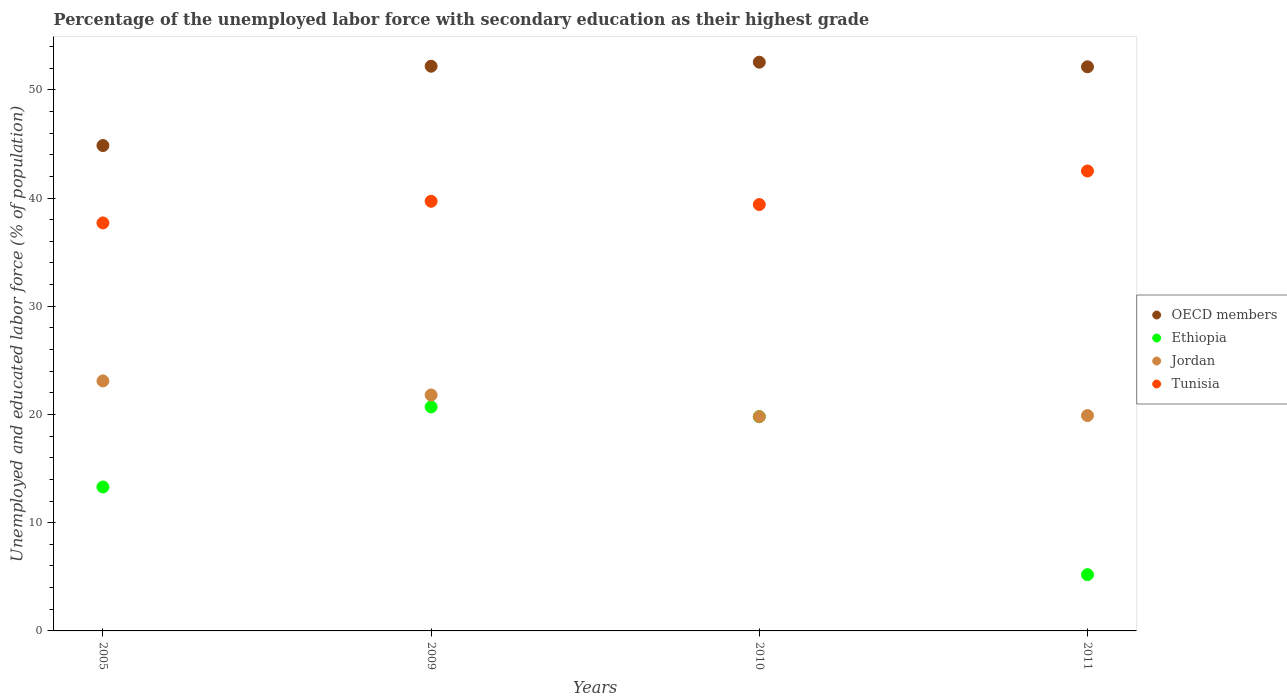What is the percentage of the unemployed labor force with secondary education in Ethiopia in 2009?
Keep it short and to the point. 20.7. Across all years, what is the maximum percentage of the unemployed labor force with secondary education in Jordan?
Ensure brevity in your answer.  23.1. Across all years, what is the minimum percentage of the unemployed labor force with secondary education in Ethiopia?
Make the answer very short. 5.2. What is the total percentage of the unemployed labor force with secondary education in Jordan in the graph?
Your answer should be very brief. 84.6. What is the difference between the percentage of the unemployed labor force with secondary education in Ethiopia in 2009 and that in 2011?
Your answer should be compact. 15.5. What is the difference between the percentage of the unemployed labor force with secondary education in OECD members in 2011 and the percentage of the unemployed labor force with secondary education in Jordan in 2010?
Give a very brief answer. 32.33. What is the average percentage of the unemployed labor force with secondary education in OECD members per year?
Keep it short and to the point. 50.43. In the year 2005, what is the difference between the percentage of the unemployed labor force with secondary education in OECD members and percentage of the unemployed labor force with secondary education in Ethiopia?
Provide a short and direct response. 31.55. What is the ratio of the percentage of the unemployed labor force with secondary education in OECD members in 2005 to that in 2010?
Make the answer very short. 0.85. Is the difference between the percentage of the unemployed labor force with secondary education in OECD members in 2010 and 2011 greater than the difference between the percentage of the unemployed labor force with secondary education in Ethiopia in 2010 and 2011?
Provide a short and direct response. No. What is the difference between the highest and the second highest percentage of the unemployed labor force with secondary education in Ethiopia?
Make the answer very short. 0.9. What is the difference between the highest and the lowest percentage of the unemployed labor force with secondary education in Jordan?
Keep it short and to the point. 3.3. Is it the case that in every year, the sum of the percentage of the unemployed labor force with secondary education in Jordan and percentage of the unemployed labor force with secondary education in Ethiopia  is greater than the sum of percentage of the unemployed labor force with secondary education in OECD members and percentage of the unemployed labor force with secondary education in Tunisia?
Your answer should be very brief. Yes. Is it the case that in every year, the sum of the percentage of the unemployed labor force with secondary education in OECD members and percentage of the unemployed labor force with secondary education in Jordan  is greater than the percentage of the unemployed labor force with secondary education in Tunisia?
Give a very brief answer. Yes. Is the percentage of the unemployed labor force with secondary education in Ethiopia strictly less than the percentage of the unemployed labor force with secondary education in OECD members over the years?
Your answer should be very brief. Yes. How many dotlines are there?
Offer a very short reply. 4. How many years are there in the graph?
Make the answer very short. 4. What is the difference between two consecutive major ticks on the Y-axis?
Make the answer very short. 10. Are the values on the major ticks of Y-axis written in scientific E-notation?
Your response must be concise. No. Does the graph contain any zero values?
Offer a terse response. No. Where does the legend appear in the graph?
Make the answer very short. Center right. How are the legend labels stacked?
Your answer should be very brief. Vertical. What is the title of the graph?
Provide a succinct answer. Percentage of the unemployed labor force with secondary education as their highest grade. Does "Tuvalu" appear as one of the legend labels in the graph?
Offer a terse response. No. What is the label or title of the X-axis?
Keep it short and to the point. Years. What is the label or title of the Y-axis?
Your answer should be very brief. Unemployed and educated labor force (% of population). What is the Unemployed and educated labor force (% of population) of OECD members in 2005?
Provide a succinct answer. 44.85. What is the Unemployed and educated labor force (% of population) in Ethiopia in 2005?
Your response must be concise. 13.3. What is the Unemployed and educated labor force (% of population) in Jordan in 2005?
Provide a succinct answer. 23.1. What is the Unemployed and educated labor force (% of population) of Tunisia in 2005?
Make the answer very short. 37.7. What is the Unemployed and educated labor force (% of population) of OECD members in 2009?
Your answer should be very brief. 52.18. What is the Unemployed and educated labor force (% of population) of Ethiopia in 2009?
Keep it short and to the point. 20.7. What is the Unemployed and educated labor force (% of population) of Jordan in 2009?
Make the answer very short. 21.8. What is the Unemployed and educated labor force (% of population) in Tunisia in 2009?
Ensure brevity in your answer.  39.7. What is the Unemployed and educated labor force (% of population) in OECD members in 2010?
Offer a very short reply. 52.55. What is the Unemployed and educated labor force (% of population) in Ethiopia in 2010?
Provide a short and direct response. 19.8. What is the Unemployed and educated labor force (% of population) in Jordan in 2010?
Provide a succinct answer. 19.8. What is the Unemployed and educated labor force (% of population) in Tunisia in 2010?
Offer a terse response. 39.4. What is the Unemployed and educated labor force (% of population) in OECD members in 2011?
Your answer should be very brief. 52.13. What is the Unemployed and educated labor force (% of population) in Ethiopia in 2011?
Offer a terse response. 5.2. What is the Unemployed and educated labor force (% of population) of Jordan in 2011?
Your response must be concise. 19.9. What is the Unemployed and educated labor force (% of population) in Tunisia in 2011?
Give a very brief answer. 42.5. Across all years, what is the maximum Unemployed and educated labor force (% of population) of OECD members?
Your response must be concise. 52.55. Across all years, what is the maximum Unemployed and educated labor force (% of population) of Ethiopia?
Ensure brevity in your answer.  20.7. Across all years, what is the maximum Unemployed and educated labor force (% of population) in Jordan?
Offer a very short reply. 23.1. Across all years, what is the maximum Unemployed and educated labor force (% of population) in Tunisia?
Offer a terse response. 42.5. Across all years, what is the minimum Unemployed and educated labor force (% of population) of OECD members?
Your response must be concise. 44.85. Across all years, what is the minimum Unemployed and educated labor force (% of population) in Ethiopia?
Offer a terse response. 5.2. Across all years, what is the minimum Unemployed and educated labor force (% of population) in Jordan?
Your answer should be very brief. 19.8. Across all years, what is the minimum Unemployed and educated labor force (% of population) in Tunisia?
Ensure brevity in your answer.  37.7. What is the total Unemployed and educated labor force (% of population) in OECD members in the graph?
Your response must be concise. 201.71. What is the total Unemployed and educated labor force (% of population) in Ethiopia in the graph?
Provide a succinct answer. 59. What is the total Unemployed and educated labor force (% of population) of Jordan in the graph?
Keep it short and to the point. 84.6. What is the total Unemployed and educated labor force (% of population) in Tunisia in the graph?
Your answer should be compact. 159.3. What is the difference between the Unemployed and educated labor force (% of population) of OECD members in 2005 and that in 2009?
Offer a very short reply. -7.33. What is the difference between the Unemployed and educated labor force (% of population) of Tunisia in 2005 and that in 2009?
Give a very brief answer. -2. What is the difference between the Unemployed and educated labor force (% of population) in OECD members in 2005 and that in 2010?
Keep it short and to the point. -7.7. What is the difference between the Unemployed and educated labor force (% of population) in OECD members in 2005 and that in 2011?
Your response must be concise. -7.28. What is the difference between the Unemployed and educated labor force (% of population) of Jordan in 2005 and that in 2011?
Your response must be concise. 3.2. What is the difference between the Unemployed and educated labor force (% of population) of Tunisia in 2005 and that in 2011?
Make the answer very short. -4.8. What is the difference between the Unemployed and educated labor force (% of population) of OECD members in 2009 and that in 2010?
Make the answer very short. -0.37. What is the difference between the Unemployed and educated labor force (% of population) of Ethiopia in 2009 and that in 2010?
Offer a terse response. 0.9. What is the difference between the Unemployed and educated labor force (% of population) of Jordan in 2009 and that in 2010?
Offer a very short reply. 2. What is the difference between the Unemployed and educated labor force (% of population) of OECD members in 2009 and that in 2011?
Keep it short and to the point. 0.05. What is the difference between the Unemployed and educated labor force (% of population) in Jordan in 2009 and that in 2011?
Ensure brevity in your answer.  1.9. What is the difference between the Unemployed and educated labor force (% of population) of Tunisia in 2009 and that in 2011?
Your response must be concise. -2.8. What is the difference between the Unemployed and educated labor force (% of population) in OECD members in 2010 and that in 2011?
Offer a terse response. 0.43. What is the difference between the Unemployed and educated labor force (% of population) of Ethiopia in 2010 and that in 2011?
Provide a succinct answer. 14.6. What is the difference between the Unemployed and educated labor force (% of population) of Jordan in 2010 and that in 2011?
Ensure brevity in your answer.  -0.1. What is the difference between the Unemployed and educated labor force (% of population) of OECD members in 2005 and the Unemployed and educated labor force (% of population) of Ethiopia in 2009?
Offer a terse response. 24.15. What is the difference between the Unemployed and educated labor force (% of population) of OECD members in 2005 and the Unemployed and educated labor force (% of population) of Jordan in 2009?
Provide a succinct answer. 23.05. What is the difference between the Unemployed and educated labor force (% of population) in OECD members in 2005 and the Unemployed and educated labor force (% of population) in Tunisia in 2009?
Keep it short and to the point. 5.15. What is the difference between the Unemployed and educated labor force (% of population) in Ethiopia in 2005 and the Unemployed and educated labor force (% of population) in Jordan in 2009?
Ensure brevity in your answer.  -8.5. What is the difference between the Unemployed and educated labor force (% of population) in Ethiopia in 2005 and the Unemployed and educated labor force (% of population) in Tunisia in 2009?
Offer a very short reply. -26.4. What is the difference between the Unemployed and educated labor force (% of population) of Jordan in 2005 and the Unemployed and educated labor force (% of population) of Tunisia in 2009?
Offer a very short reply. -16.6. What is the difference between the Unemployed and educated labor force (% of population) in OECD members in 2005 and the Unemployed and educated labor force (% of population) in Ethiopia in 2010?
Provide a short and direct response. 25.05. What is the difference between the Unemployed and educated labor force (% of population) in OECD members in 2005 and the Unemployed and educated labor force (% of population) in Jordan in 2010?
Make the answer very short. 25.05. What is the difference between the Unemployed and educated labor force (% of population) in OECD members in 2005 and the Unemployed and educated labor force (% of population) in Tunisia in 2010?
Your response must be concise. 5.45. What is the difference between the Unemployed and educated labor force (% of population) in Ethiopia in 2005 and the Unemployed and educated labor force (% of population) in Tunisia in 2010?
Ensure brevity in your answer.  -26.1. What is the difference between the Unemployed and educated labor force (% of population) of Jordan in 2005 and the Unemployed and educated labor force (% of population) of Tunisia in 2010?
Make the answer very short. -16.3. What is the difference between the Unemployed and educated labor force (% of population) of OECD members in 2005 and the Unemployed and educated labor force (% of population) of Ethiopia in 2011?
Ensure brevity in your answer.  39.65. What is the difference between the Unemployed and educated labor force (% of population) of OECD members in 2005 and the Unemployed and educated labor force (% of population) of Jordan in 2011?
Keep it short and to the point. 24.95. What is the difference between the Unemployed and educated labor force (% of population) of OECD members in 2005 and the Unemployed and educated labor force (% of population) of Tunisia in 2011?
Your response must be concise. 2.35. What is the difference between the Unemployed and educated labor force (% of population) of Ethiopia in 2005 and the Unemployed and educated labor force (% of population) of Tunisia in 2011?
Make the answer very short. -29.2. What is the difference between the Unemployed and educated labor force (% of population) in Jordan in 2005 and the Unemployed and educated labor force (% of population) in Tunisia in 2011?
Your response must be concise. -19.4. What is the difference between the Unemployed and educated labor force (% of population) of OECD members in 2009 and the Unemployed and educated labor force (% of population) of Ethiopia in 2010?
Your answer should be very brief. 32.38. What is the difference between the Unemployed and educated labor force (% of population) in OECD members in 2009 and the Unemployed and educated labor force (% of population) in Jordan in 2010?
Give a very brief answer. 32.38. What is the difference between the Unemployed and educated labor force (% of population) in OECD members in 2009 and the Unemployed and educated labor force (% of population) in Tunisia in 2010?
Offer a very short reply. 12.78. What is the difference between the Unemployed and educated labor force (% of population) in Ethiopia in 2009 and the Unemployed and educated labor force (% of population) in Jordan in 2010?
Provide a succinct answer. 0.9. What is the difference between the Unemployed and educated labor force (% of population) in Ethiopia in 2009 and the Unemployed and educated labor force (% of population) in Tunisia in 2010?
Provide a short and direct response. -18.7. What is the difference between the Unemployed and educated labor force (% of population) in Jordan in 2009 and the Unemployed and educated labor force (% of population) in Tunisia in 2010?
Your response must be concise. -17.6. What is the difference between the Unemployed and educated labor force (% of population) in OECD members in 2009 and the Unemployed and educated labor force (% of population) in Ethiopia in 2011?
Give a very brief answer. 46.98. What is the difference between the Unemployed and educated labor force (% of population) in OECD members in 2009 and the Unemployed and educated labor force (% of population) in Jordan in 2011?
Give a very brief answer. 32.28. What is the difference between the Unemployed and educated labor force (% of population) of OECD members in 2009 and the Unemployed and educated labor force (% of population) of Tunisia in 2011?
Provide a succinct answer. 9.68. What is the difference between the Unemployed and educated labor force (% of population) of Ethiopia in 2009 and the Unemployed and educated labor force (% of population) of Tunisia in 2011?
Make the answer very short. -21.8. What is the difference between the Unemployed and educated labor force (% of population) of Jordan in 2009 and the Unemployed and educated labor force (% of population) of Tunisia in 2011?
Offer a terse response. -20.7. What is the difference between the Unemployed and educated labor force (% of population) in OECD members in 2010 and the Unemployed and educated labor force (% of population) in Ethiopia in 2011?
Make the answer very short. 47.35. What is the difference between the Unemployed and educated labor force (% of population) of OECD members in 2010 and the Unemployed and educated labor force (% of population) of Jordan in 2011?
Give a very brief answer. 32.65. What is the difference between the Unemployed and educated labor force (% of population) of OECD members in 2010 and the Unemployed and educated labor force (% of population) of Tunisia in 2011?
Offer a terse response. 10.05. What is the difference between the Unemployed and educated labor force (% of population) of Ethiopia in 2010 and the Unemployed and educated labor force (% of population) of Jordan in 2011?
Your answer should be compact. -0.1. What is the difference between the Unemployed and educated labor force (% of population) in Ethiopia in 2010 and the Unemployed and educated labor force (% of population) in Tunisia in 2011?
Offer a terse response. -22.7. What is the difference between the Unemployed and educated labor force (% of population) of Jordan in 2010 and the Unemployed and educated labor force (% of population) of Tunisia in 2011?
Provide a short and direct response. -22.7. What is the average Unemployed and educated labor force (% of population) in OECD members per year?
Offer a very short reply. 50.43. What is the average Unemployed and educated labor force (% of population) in Ethiopia per year?
Provide a short and direct response. 14.75. What is the average Unemployed and educated labor force (% of population) of Jordan per year?
Your answer should be compact. 21.15. What is the average Unemployed and educated labor force (% of population) in Tunisia per year?
Provide a short and direct response. 39.83. In the year 2005, what is the difference between the Unemployed and educated labor force (% of population) in OECD members and Unemployed and educated labor force (% of population) in Ethiopia?
Your answer should be very brief. 31.55. In the year 2005, what is the difference between the Unemployed and educated labor force (% of population) of OECD members and Unemployed and educated labor force (% of population) of Jordan?
Offer a very short reply. 21.75. In the year 2005, what is the difference between the Unemployed and educated labor force (% of population) in OECD members and Unemployed and educated labor force (% of population) in Tunisia?
Provide a short and direct response. 7.15. In the year 2005, what is the difference between the Unemployed and educated labor force (% of population) in Ethiopia and Unemployed and educated labor force (% of population) in Jordan?
Your response must be concise. -9.8. In the year 2005, what is the difference between the Unemployed and educated labor force (% of population) in Ethiopia and Unemployed and educated labor force (% of population) in Tunisia?
Offer a very short reply. -24.4. In the year 2005, what is the difference between the Unemployed and educated labor force (% of population) in Jordan and Unemployed and educated labor force (% of population) in Tunisia?
Your answer should be compact. -14.6. In the year 2009, what is the difference between the Unemployed and educated labor force (% of population) in OECD members and Unemployed and educated labor force (% of population) in Ethiopia?
Offer a very short reply. 31.48. In the year 2009, what is the difference between the Unemployed and educated labor force (% of population) in OECD members and Unemployed and educated labor force (% of population) in Jordan?
Your answer should be compact. 30.38. In the year 2009, what is the difference between the Unemployed and educated labor force (% of population) in OECD members and Unemployed and educated labor force (% of population) in Tunisia?
Provide a succinct answer. 12.48. In the year 2009, what is the difference between the Unemployed and educated labor force (% of population) in Jordan and Unemployed and educated labor force (% of population) in Tunisia?
Make the answer very short. -17.9. In the year 2010, what is the difference between the Unemployed and educated labor force (% of population) of OECD members and Unemployed and educated labor force (% of population) of Ethiopia?
Give a very brief answer. 32.75. In the year 2010, what is the difference between the Unemployed and educated labor force (% of population) of OECD members and Unemployed and educated labor force (% of population) of Jordan?
Your answer should be very brief. 32.75. In the year 2010, what is the difference between the Unemployed and educated labor force (% of population) in OECD members and Unemployed and educated labor force (% of population) in Tunisia?
Keep it short and to the point. 13.15. In the year 2010, what is the difference between the Unemployed and educated labor force (% of population) in Ethiopia and Unemployed and educated labor force (% of population) in Jordan?
Your response must be concise. 0. In the year 2010, what is the difference between the Unemployed and educated labor force (% of population) of Ethiopia and Unemployed and educated labor force (% of population) of Tunisia?
Provide a succinct answer. -19.6. In the year 2010, what is the difference between the Unemployed and educated labor force (% of population) of Jordan and Unemployed and educated labor force (% of population) of Tunisia?
Keep it short and to the point. -19.6. In the year 2011, what is the difference between the Unemployed and educated labor force (% of population) of OECD members and Unemployed and educated labor force (% of population) of Ethiopia?
Make the answer very short. 46.93. In the year 2011, what is the difference between the Unemployed and educated labor force (% of population) of OECD members and Unemployed and educated labor force (% of population) of Jordan?
Give a very brief answer. 32.23. In the year 2011, what is the difference between the Unemployed and educated labor force (% of population) of OECD members and Unemployed and educated labor force (% of population) of Tunisia?
Offer a very short reply. 9.63. In the year 2011, what is the difference between the Unemployed and educated labor force (% of population) in Ethiopia and Unemployed and educated labor force (% of population) in Jordan?
Your response must be concise. -14.7. In the year 2011, what is the difference between the Unemployed and educated labor force (% of population) of Ethiopia and Unemployed and educated labor force (% of population) of Tunisia?
Provide a short and direct response. -37.3. In the year 2011, what is the difference between the Unemployed and educated labor force (% of population) in Jordan and Unemployed and educated labor force (% of population) in Tunisia?
Your answer should be compact. -22.6. What is the ratio of the Unemployed and educated labor force (% of population) in OECD members in 2005 to that in 2009?
Provide a short and direct response. 0.86. What is the ratio of the Unemployed and educated labor force (% of population) of Ethiopia in 2005 to that in 2009?
Your response must be concise. 0.64. What is the ratio of the Unemployed and educated labor force (% of population) of Jordan in 2005 to that in 2009?
Offer a terse response. 1.06. What is the ratio of the Unemployed and educated labor force (% of population) of Tunisia in 2005 to that in 2009?
Offer a very short reply. 0.95. What is the ratio of the Unemployed and educated labor force (% of population) of OECD members in 2005 to that in 2010?
Provide a short and direct response. 0.85. What is the ratio of the Unemployed and educated labor force (% of population) in Ethiopia in 2005 to that in 2010?
Ensure brevity in your answer.  0.67. What is the ratio of the Unemployed and educated labor force (% of population) in Jordan in 2005 to that in 2010?
Your answer should be compact. 1.17. What is the ratio of the Unemployed and educated labor force (% of population) of Tunisia in 2005 to that in 2010?
Offer a very short reply. 0.96. What is the ratio of the Unemployed and educated labor force (% of population) in OECD members in 2005 to that in 2011?
Provide a short and direct response. 0.86. What is the ratio of the Unemployed and educated labor force (% of population) of Ethiopia in 2005 to that in 2011?
Offer a very short reply. 2.56. What is the ratio of the Unemployed and educated labor force (% of population) in Jordan in 2005 to that in 2011?
Offer a very short reply. 1.16. What is the ratio of the Unemployed and educated labor force (% of population) in Tunisia in 2005 to that in 2011?
Offer a terse response. 0.89. What is the ratio of the Unemployed and educated labor force (% of population) in OECD members in 2009 to that in 2010?
Make the answer very short. 0.99. What is the ratio of the Unemployed and educated labor force (% of population) in Ethiopia in 2009 to that in 2010?
Offer a very short reply. 1.05. What is the ratio of the Unemployed and educated labor force (% of population) of Jordan in 2009 to that in 2010?
Make the answer very short. 1.1. What is the ratio of the Unemployed and educated labor force (% of population) in Tunisia in 2009 to that in 2010?
Offer a very short reply. 1.01. What is the ratio of the Unemployed and educated labor force (% of population) in Ethiopia in 2009 to that in 2011?
Offer a terse response. 3.98. What is the ratio of the Unemployed and educated labor force (% of population) of Jordan in 2009 to that in 2011?
Make the answer very short. 1.1. What is the ratio of the Unemployed and educated labor force (% of population) in Tunisia in 2009 to that in 2011?
Your answer should be very brief. 0.93. What is the ratio of the Unemployed and educated labor force (% of population) in OECD members in 2010 to that in 2011?
Keep it short and to the point. 1.01. What is the ratio of the Unemployed and educated labor force (% of population) of Ethiopia in 2010 to that in 2011?
Your answer should be very brief. 3.81. What is the ratio of the Unemployed and educated labor force (% of population) of Tunisia in 2010 to that in 2011?
Offer a very short reply. 0.93. What is the difference between the highest and the second highest Unemployed and educated labor force (% of population) in OECD members?
Offer a terse response. 0.37. What is the difference between the highest and the second highest Unemployed and educated labor force (% of population) in Ethiopia?
Offer a terse response. 0.9. What is the difference between the highest and the second highest Unemployed and educated labor force (% of population) in Jordan?
Your answer should be very brief. 1.3. What is the difference between the highest and the second highest Unemployed and educated labor force (% of population) in Tunisia?
Provide a short and direct response. 2.8. What is the difference between the highest and the lowest Unemployed and educated labor force (% of population) of OECD members?
Offer a very short reply. 7.7. What is the difference between the highest and the lowest Unemployed and educated labor force (% of population) in Tunisia?
Your response must be concise. 4.8. 